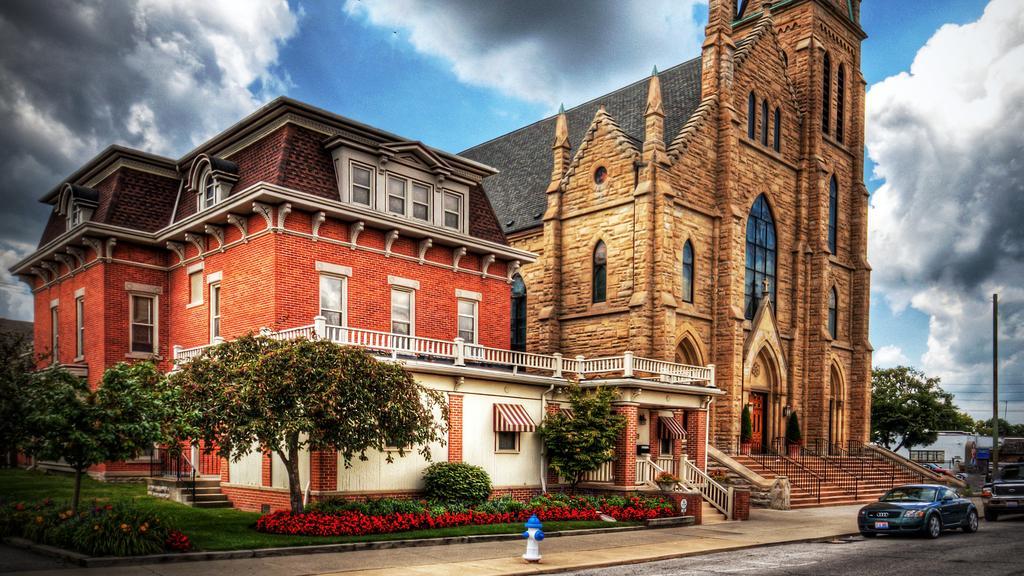Please provide a concise description of this image. In this picture we can see building and church. On the bottom there is a fire hydrant on the street. On the bottom right corner we can see two cars on the road, beside that we can see stairs. On the left we can see many trees, plants, flowers and grass. On the right there is a pole which is near to the shop. On the top we can see sky and clouds. 